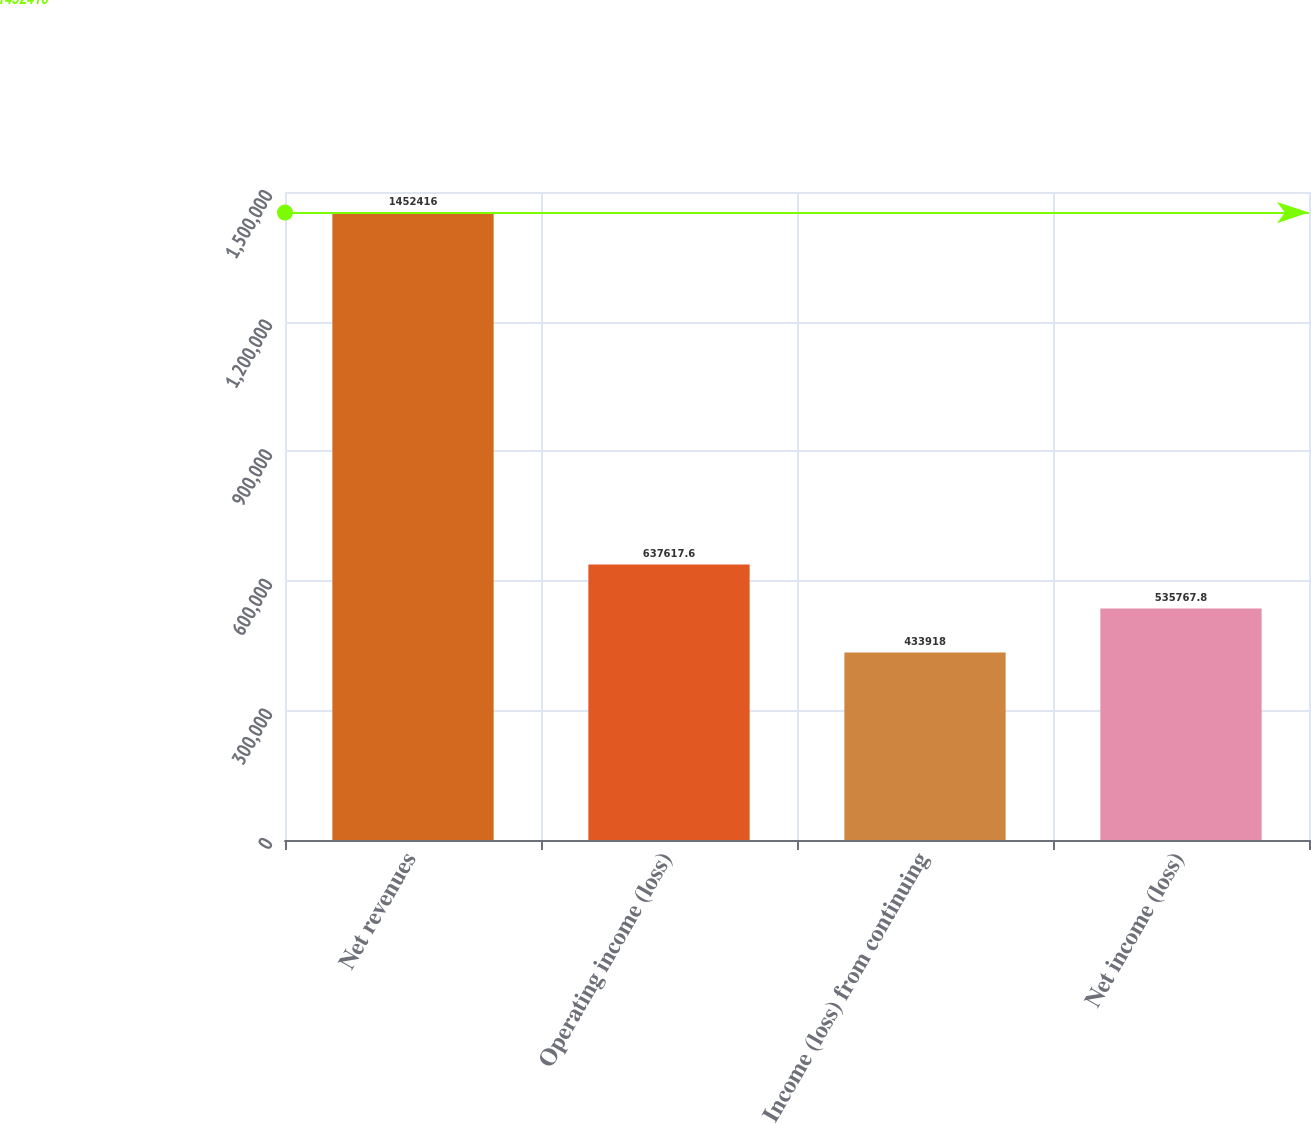Convert chart to OTSL. <chart><loc_0><loc_0><loc_500><loc_500><bar_chart><fcel>Net revenues<fcel>Operating income (loss)<fcel>Income (loss) from continuing<fcel>Net income (loss)<nl><fcel>1.45242e+06<fcel>637618<fcel>433918<fcel>535768<nl></chart> 